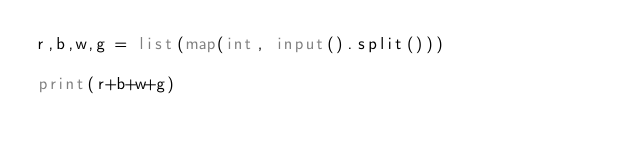<code> <loc_0><loc_0><loc_500><loc_500><_Python_>r,b,w,g = list(map(int, input().split()))

print(r+b+w+g)
</code> 